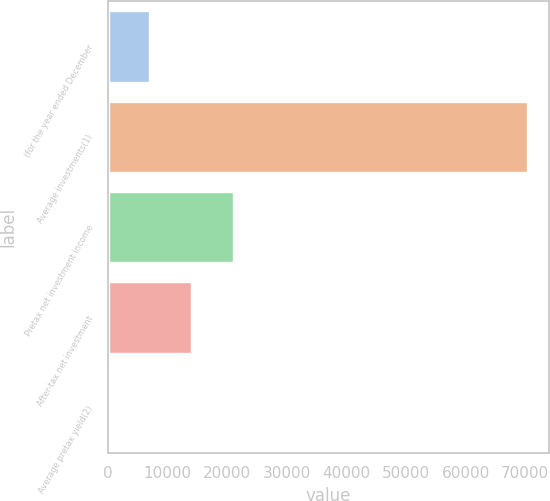Convert chart to OTSL. <chart><loc_0><loc_0><loc_500><loc_500><bar_chart><fcel>(for the year ended December<fcel>Average investments(1)<fcel>Pretax net investment income<fcel>After-tax net investment<fcel>Average pretax yield(2)<nl><fcel>7050.79<fcel>70471<fcel>21144.2<fcel>14097.5<fcel>4.1<nl></chart> 